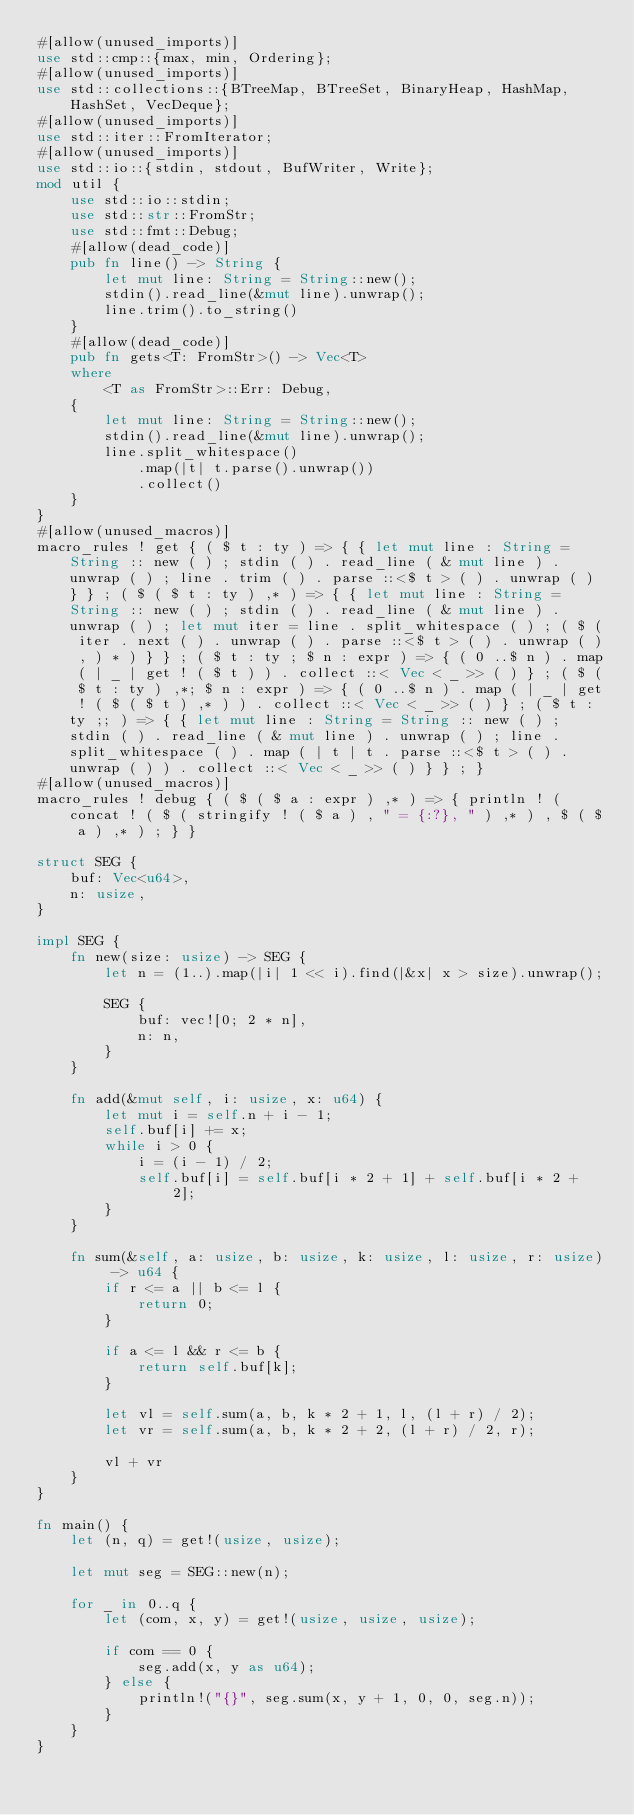<code> <loc_0><loc_0><loc_500><loc_500><_Rust_>#[allow(unused_imports)]
use std::cmp::{max, min, Ordering};
#[allow(unused_imports)]
use std::collections::{BTreeMap, BTreeSet, BinaryHeap, HashMap, HashSet, VecDeque};
#[allow(unused_imports)]
use std::iter::FromIterator;
#[allow(unused_imports)]
use std::io::{stdin, stdout, BufWriter, Write};
mod util {
    use std::io::stdin;
    use std::str::FromStr;
    use std::fmt::Debug;
    #[allow(dead_code)]
    pub fn line() -> String {
        let mut line: String = String::new();
        stdin().read_line(&mut line).unwrap();
        line.trim().to_string()
    }
    #[allow(dead_code)]
    pub fn gets<T: FromStr>() -> Vec<T>
    where
        <T as FromStr>::Err: Debug,
    {
        let mut line: String = String::new();
        stdin().read_line(&mut line).unwrap();
        line.split_whitespace()
            .map(|t| t.parse().unwrap())
            .collect()
    }
}
#[allow(unused_macros)]
macro_rules ! get { ( $ t : ty ) => { { let mut line : String = String :: new ( ) ; stdin ( ) . read_line ( & mut line ) . unwrap ( ) ; line . trim ( ) . parse ::<$ t > ( ) . unwrap ( ) } } ; ( $ ( $ t : ty ) ,* ) => { { let mut line : String = String :: new ( ) ; stdin ( ) . read_line ( & mut line ) . unwrap ( ) ; let mut iter = line . split_whitespace ( ) ; ( $ ( iter . next ( ) . unwrap ( ) . parse ::<$ t > ( ) . unwrap ( ) , ) * ) } } ; ( $ t : ty ; $ n : expr ) => { ( 0 ..$ n ) . map ( | _ | get ! ( $ t ) ) . collect ::< Vec < _ >> ( ) } ; ( $ ( $ t : ty ) ,*; $ n : expr ) => { ( 0 ..$ n ) . map ( | _ | get ! ( $ ( $ t ) ,* ) ) . collect ::< Vec < _ >> ( ) } ; ( $ t : ty ;; ) => { { let mut line : String = String :: new ( ) ; stdin ( ) . read_line ( & mut line ) . unwrap ( ) ; line . split_whitespace ( ) . map ( | t | t . parse ::<$ t > ( ) . unwrap ( ) ) . collect ::< Vec < _ >> ( ) } } ; }
#[allow(unused_macros)]
macro_rules ! debug { ( $ ( $ a : expr ) ,* ) => { println ! ( concat ! ( $ ( stringify ! ( $ a ) , " = {:?}, " ) ,* ) , $ ( $ a ) ,* ) ; } }

struct SEG {
    buf: Vec<u64>,
    n: usize,
}

impl SEG {
    fn new(size: usize) -> SEG {
        let n = (1..).map(|i| 1 << i).find(|&x| x > size).unwrap();

        SEG {
            buf: vec![0; 2 * n],
            n: n,
        }
    }

    fn add(&mut self, i: usize, x: u64) {
        let mut i = self.n + i - 1;
        self.buf[i] += x;
        while i > 0 {
            i = (i - 1) / 2;
            self.buf[i] = self.buf[i * 2 + 1] + self.buf[i * 2 + 2];
        }
    }

    fn sum(&self, a: usize, b: usize, k: usize, l: usize, r: usize) -> u64 {
        if r <= a || b <= l {
            return 0;
        }

        if a <= l && r <= b {
            return self.buf[k];
        }

        let vl = self.sum(a, b, k * 2 + 1, l, (l + r) / 2);
        let vr = self.sum(a, b, k * 2 + 2, (l + r) / 2, r);

        vl + vr
    }
}

fn main() {
    let (n, q) = get!(usize, usize);

    let mut seg = SEG::new(n);

    for _ in 0..q {
        let (com, x, y) = get!(usize, usize, usize);

        if com == 0 {
            seg.add(x, y as u64);
        } else {
            println!("{}", seg.sum(x, y + 1, 0, 0, seg.n));
        }
    }
}

</code> 